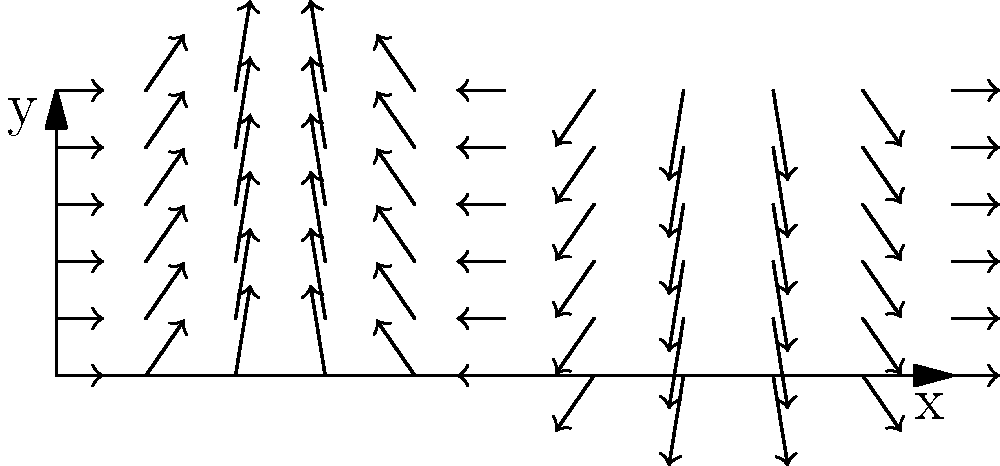As a body painter, you want to optimize your brush stroke pattern for covering a curved surface. The vector field shown represents the curvature of a body area. Find the line integral of the vector field $\mathbf{F}(x,y) = \langle \cos x, 2\sin x \rangle$ along the curve $C$ from $(0,0)$ to $(\pi,2)$, where $C$ is defined by $y=2\sin(x/2)$ for $0 \leq x \leq \pi$. This will help determine the most efficient brush stroke pattern. To solve this optimization problem, we need to calculate the line integral:

1) The vector field is $\mathbf{F}(x,y) = \langle \cos x, 2\sin x \rangle$

2) The curve $C$ is defined by $y=2\sin(x/2)$ for $0 \leq x \leq \pi$

3) We need to parameterize the curve. Let $x=t$, then:
   $x=t$
   $y=2\sin(t/2)$
   $0 \leq t \leq \pi$

4) Now, we need $\frac{dx}{dt}$ and $\frac{dy}{dt}$:
   $\frac{dx}{dt} = 1$
   $\frac{dy}{dt} = \cos(t/2)$

5) The line integral is given by:
   $$\int_C \mathbf{F} \cdot d\mathbf{r} = \int_0^\pi [\cos t \cdot 1 + 2\sin t \cdot \cos(t/2)] dt$$

6) Simplify:
   $$\int_0^\pi [\cos t + 2\sin t \cos(t/2)] dt$$

7) This integral can be solved using integration by parts or trigonometric substitutions. The result is:
   $$[\sin t + 4\sin^2(t/4)]_0^\pi$$

8) Evaluate the bounds:
   $(\sin \pi + 4\sin^2(\pi/4)) - (\sin 0 + 4\sin^2(0))$
   $= (0 + 4(1/\sqrt{2})^2) - (0 + 0)$
   $= 2$

Therefore, the line integral equals 2.
Answer: 2 